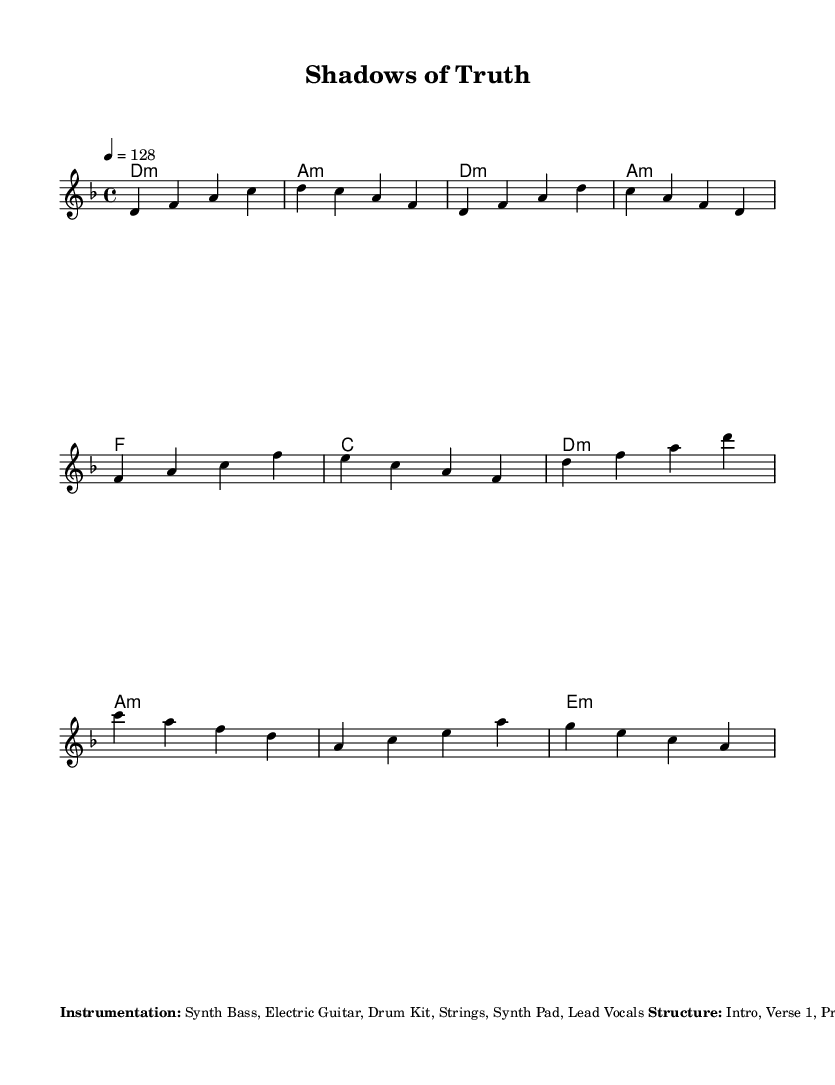What is the key signature of this music? The key signature is D minor, which has one flat (B♭). This is indicated at the beginning of the sheet music.
Answer: D minor What is the time signature of this music? The time signature is shown as 4/4, meaning there are four beats in each measure and a quarter note gets one beat. This is specified at the beginning of the sheet music, right after the key signature.
Answer: 4/4 What is the tempo marking for this piece? The tempo marking indicates a speed of 128 beats per minute, as shown in the tempo indication alongside the time signature. This specific marking defines how fast the piece should be played.
Answer: 128 What instruments are specified for this piece? The instrumentation listed in the markup includes Synth Bass, Electric Guitar, Drum Kit, Strings, Synth Pad, and Lead Vocals. This is highlighted in the instrumentation section of the markup, reflecting the arrangement of the music.
Answer: Synth Bass, Electric Guitar, Drum Kit, Strings, Synth Pad, Lead Vocals How many sections are in the structure of the song? The structure mentions several parts including Intro, Verse 1, Pre-Chorus, Chorus, Verse 2, Pre-Chorus, Chorus, Bridge, Chorus, and Outro, totaling ten sections. This can be counted directly from the structural description in the markup.
Answer: 10 What type of rhythm is used in the drum pattern? The rhythm description indicates a Kick on beats 1 and 3, and Snare on beats 2 and 4, with Hi-hat playing sixteenth notes. This rhythmic pattern is noted specifically in the rhythmic section of the markup to define the drumming style in the piece.
Answer: Kick on 1 and 3, Snare on 2 and 4 What theme do the additional elements suggest about the mood of the piece? The additional elements describe mysterious, atmospheric sounds and detective-themed samples, suggesting the mood aligns with intense mystery and drama themes. This is reflective of the K-Pop genre influences in the piece's overall presentation.
Answer: Mysterious and dramatic 